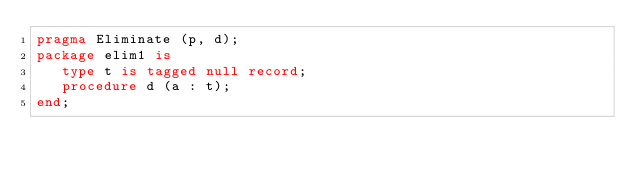<code> <loc_0><loc_0><loc_500><loc_500><_Ada_>pragma Eliminate (p, d);
package elim1 is
   type t is tagged null record;
   procedure d (a : t);       
end;
</code> 